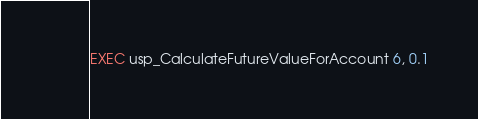<code> <loc_0><loc_0><loc_500><loc_500><_SQL_>
EXEC usp_CalculateFutureValueForAccount 6, 0.1

</code> 